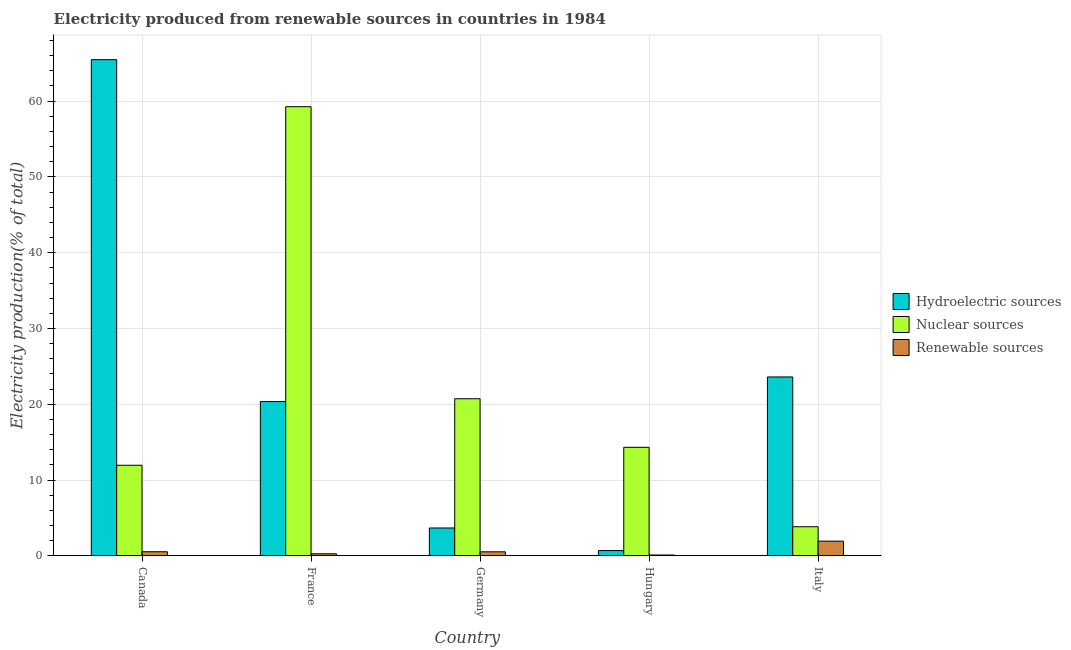How many groups of bars are there?
Give a very brief answer. 5. Are the number of bars per tick equal to the number of legend labels?
Make the answer very short. Yes. Are the number of bars on each tick of the X-axis equal?
Your answer should be compact. Yes. How many bars are there on the 2nd tick from the left?
Provide a short and direct response. 3. How many bars are there on the 1st tick from the right?
Provide a short and direct response. 3. What is the label of the 1st group of bars from the left?
Offer a terse response. Canada. In how many cases, is the number of bars for a given country not equal to the number of legend labels?
Your response must be concise. 0. What is the percentage of electricity produced by hydroelectric sources in Germany?
Make the answer very short. 3.67. Across all countries, what is the maximum percentage of electricity produced by hydroelectric sources?
Ensure brevity in your answer.  65.47. Across all countries, what is the minimum percentage of electricity produced by renewable sources?
Make the answer very short. 0.1. In which country was the percentage of electricity produced by hydroelectric sources minimum?
Provide a succinct answer. Hungary. What is the total percentage of electricity produced by nuclear sources in the graph?
Offer a terse response. 110.1. What is the difference between the percentage of electricity produced by renewable sources in Canada and that in Italy?
Provide a short and direct response. -1.4. What is the difference between the percentage of electricity produced by renewable sources in Canada and the percentage of electricity produced by hydroelectric sources in Hungary?
Make the answer very short. -0.15. What is the average percentage of electricity produced by hydroelectric sources per country?
Ensure brevity in your answer.  22.76. What is the difference between the percentage of electricity produced by hydroelectric sources and percentage of electricity produced by nuclear sources in Italy?
Your answer should be compact. 19.77. What is the ratio of the percentage of electricity produced by nuclear sources in France to that in Germany?
Ensure brevity in your answer.  2.86. Is the percentage of electricity produced by nuclear sources in Canada less than that in Hungary?
Your answer should be very brief. Yes. What is the difference between the highest and the second highest percentage of electricity produced by nuclear sources?
Provide a short and direct response. 38.54. What is the difference between the highest and the lowest percentage of electricity produced by nuclear sources?
Keep it short and to the point. 55.44. In how many countries, is the percentage of electricity produced by renewable sources greater than the average percentage of electricity produced by renewable sources taken over all countries?
Your answer should be compact. 1. What does the 1st bar from the left in Germany represents?
Your answer should be very brief. Hydroelectric sources. What does the 3rd bar from the right in France represents?
Give a very brief answer. Hydroelectric sources. How many bars are there?
Give a very brief answer. 15. How many countries are there in the graph?
Offer a terse response. 5. Does the graph contain any zero values?
Give a very brief answer. No. Does the graph contain grids?
Provide a short and direct response. Yes. Where does the legend appear in the graph?
Ensure brevity in your answer.  Center right. How many legend labels are there?
Make the answer very short. 3. What is the title of the graph?
Give a very brief answer. Electricity produced from renewable sources in countries in 1984. Does "Methane" appear as one of the legend labels in the graph?
Offer a terse response. No. What is the label or title of the X-axis?
Keep it short and to the point. Country. What is the label or title of the Y-axis?
Offer a terse response. Electricity production(% of total). What is the Electricity production(% of total) in Hydroelectric sources in Canada?
Provide a succinct answer. 65.47. What is the Electricity production(% of total) of Nuclear sources in Canada?
Your answer should be compact. 11.95. What is the Electricity production(% of total) of Renewable sources in Canada?
Give a very brief answer. 0.53. What is the Electricity production(% of total) of Hydroelectric sources in France?
Offer a terse response. 20.36. What is the Electricity production(% of total) of Nuclear sources in France?
Keep it short and to the point. 59.27. What is the Electricity production(% of total) of Renewable sources in France?
Offer a terse response. 0.27. What is the Electricity production(% of total) of Hydroelectric sources in Germany?
Offer a terse response. 3.67. What is the Electricity production(% of total) of Nuclear sources in Germany?
Offer a terse response. 20.73. What is the Electricity production(% of total) in Renewable sources in Germany?
Your response must be concise. 0.53. What is the Electricity production(% of total) of Hydroelectric sources in Hungary?
Provide a short and direct response. 0.69. What is the Electricity production(% of total) in Nuclear sources in Hungary?
Make the answer very short. 14.32. What is the Electricity production(% of total) of Renewable sources in Hungary?
Offer a very short reply. 0.1. What is the Electricity production(% of total) of Hydroelectric sources in Italy?
Offer a terse response. 23.6. What is the Electricity production(% of total) of Nuclear sources in Italy?
Keep it short and to the point. 3.83. What is the Electricity production(% of total) in Renewable sources in Italy?
Your response must be concise. 1.93. Across all countries, what is the maximum Electricity production(% of total) of Hydroelectric sources?
Give a very brief answer. 65.47. Across all countries, what is the maximum Electricity production(% of total) in Nuclear sources?
Your response must be concise. 59.27. Across all countries, what is the maximum Electricity production(% of total) of Renewable sources?
Make the answer very short. 1.93. Across all countries, what is the minimum Electricity production(% of total) of Hydroelectric sources?
Your response must be concise. 0.69. Across all countries, what is the minimum Electricity production(% of total) in Nuclear sources?
Offer a terse response. 3.83. Across all countries, what is the minimum Electricity production(% of total) of Renewable sources?
Make the answer very short. 0.1. What is the total Electricity production(% of total) of Hydroelectric sources in the graph?
Offer a terse response. 113.79. What is the total Electricity production(% of total) in Nuclear sources in the graph?
Offer a terse response. 110.1. What is the total Electricity production(% of total) in Renewable sources in the graph?
Your answer should be very brief. 3.36. What is the difference between the Electricity production(% of total) in Hydroelectric sources in Canada and that in France?
Make the answer very short. 45.12. What is the difference between the Electricity production(% of total) in Nuclear sources in Canada and that in France?
Make the answer very short. -47.32. What is the difference between the Electricity production(% of total) of Renewable sources in Canada and that in France?
Your response must be concise. 0.27. What is the difference between the Electricity production(% of total) of Hydroelectric sources in Canada and that in Germany?
Your answer should be compact. 61.8. What is the difference between the Electricity production(% of total) of Nuclear sources in Canada and that in Germany?
Make the answer very short. -8.78. What is the difference between the Electricity production(% of total) of Renewable sources in Canada and that in Germany?
Your answer should be compact. 0.01. What is the difference between the Electricity production(% of total) in Hydroelectric sources in Canada and that in Hungary?
Ensure brevity in your answer.  64.78. What is the difference between the Electricity production(% of total) in Nuclear sources in Canada and that in Hungary?
Your answer should be very brief. -2.37. What is the difference between the Electricity production(% of total) in Renewable sources in Canada and that in Hungary?
Provide a short and direct response. 0.43. What is the difference between the Electricity production(% of total) of Hydroelectric sources in Canada and that in Italy?
Your answer should be very brief. 41.87. What is the difference between the Electricity production(% of total) in Nuclear sources in Canada and that in Italy?
Offer a very short reply. 8.11. What is the difference between the Electricity production(% of total) of Renewable sources in Canada and that in Italy?
Give a very brief answer. -1.4. What is the difference between the Electricity production(% of total) of Hydroelectric sources in France and that in Germany?
Ensure brevity in your answer.  16.69. What is the difference between the Electricity production(% of total) in Nuclear sources in France and that in Germany?
Make the answer very short. 38.54. What is the difference between the Electricity production(% of total) in Renewable sources in France and that in Germany?
Your response must be concise. -0.26. What is the difference between the Electricity production(% of total) in Hydroelectric sources in France and that in Hungary?
Offer a terse response. 19.67. What is the difference between the Electricity production(% of total) of Nuclear sources in France and that in Hungary?
Provide a succinct answer. 44.95. What is the difference between the Electricity production(% of total) of Renewable sources in France and that in Hungary?
Offer a very short reply. 0.17. What is the difference between the Electricity production(% of total) in Hydroelectric sources in France and that in Italy?
Your response must be concise. -3.25. What is the difference between the Electricity production(% of total) of Nuclear sources in France and that in Italy?
Provide a short and direct response. 55.44. What is the difference between the Electricity production(% of total) of Renewable sources in France and that in Italy?
Offer a very short reply. -1.67. What is the difference between the Electricity production(% of total) in Hydroelectric sources in Germany and that in Hungary?
Offer a terse response. 2.98. What is the difference between the Electricity production(% of total) of Nuclear sources in Germany and that in Hungary?
Provide a short and direct response. 6.41. What is the difference between the Electricity production(% of total) in Renewable sources in Germany and that in Hungary?
Provide a short and direct response. 0.42. What is the difference between the Electricity production(% of total) of Hydroelectric sources in Germany and that in Italy?
Provide a succinct answer. -19.93. What is the difference between the Electricity production(% of total) in Nuclear sources in Germany and that in Italy?
Your answer should be very brief. 16.9. What is the difference between the Electricity production(% of total) of Renewable sources in Germany and that in Italy?
Ensure brevity in your answer.  -1.41. What is the difference between the Electricity production(% of total) in Hydroelectric sources in Hungary and that in Italy?
Give a very brief answer. -22.92. What is the difference between the Electricity production(% of total) of Nuclear sources in Hungary and that in Italy?
Provide a short and direct response. 10.48. What is the difference between the Electricity production(% of total) of Renewable sources in Hungary and that in Italy?
Your response must be concise. -1.83. What is the difference between the Electricity production(% of total) of Hydroelectric sources in Canada and the Electricity production(% of total) of Nuclear sources in France?
Make the answer very short. 6.2. What is the difference between the Electricity production(% of total) in Hydroelectric sources in Canada and the Electricity production(% of total) in Renewable sources in France?
Make the answer very short. 65.21. What is the difference between the Electricity production(% of total) in Nuclear sources in Canada and the Electricity production(% of total) in Renewable sources in France?
Keep it short and to the point. 11.68. What is the difference between the Electricity production(% of total) of Hydroelectric sources in Canada and the Electricity production(% of total) of Nuclear sources in Germany?
Make the answer very short. 44.74. What is the difference between the Electricity production(% of total) in Hydroelectric sources in Canada and the Electricity production(% of total) in Renewable sources in Germany?
Provide a succinct answer. 64.95. What is the difference between the Electricity production(% of total) of Nuclear sources in Canada and the Electricity production(% of total) of Renewable sources in Germany?
Offer a very short reply. 11.42. What is the difference between the Electricity production(% of total) in Hydroelectric sources in Canada and the Electricity production(% of total) in Nuclear sources in Hungary?
Provide a succinct answer. 51.16. What is the difference between the Electricity production(% of total) in Hydroelectric sources in Canada and the Electricity production(% of total) in Renewable sources in Hungary?
Offer a very short reply. 65.37. What is the difference between the Electricity production(% of total) in Nuclear sources in Canada and the Electricity production(% of total) in Renewable sources in Hungary?
Your answer should be very brief. 11.84. What is the difference between the Electricity production(% of total) in Hydroelectric sources in Canada and the Electricity production(% of total) in Nuclear sources in Italy?
Make the answer very short. 61.64. What is the difference between the Electricity production(% of total) of Hydroelectric sources in Canada and the Electricity production(% of total) of Renewable sources in Italy?
Ensure brevity in your answer.  63.54. What is the difference between the Electricity production(% of total) in Nuclear sources in Canada and the Electricity production(% of total) in Renewable sources in Italy?
Offer a very short reply. 10.01. What is the difference between the Electricity production(% of total) in Hydroelectric sources in France and the Electricity production(% of total) in Nuclear sources in Germany?
Give a very brief answer. -0.37. What is the difference between the Electricity production(% of total) of Hydroelectric sources in France and the Electricity production(% of total) of Renewable sources in Germany?
Keep it short and to the point. 19.83. What is the difference between the Electricity production(% of total) of Nuclear sources in France and the Electricity production(% of total) of Renewable sources in Germany?
Your answer should be compact. 58.74. What is the difference between the Electricity production(% of total) of Hydroelectric sources in France and the Electricity production(% of total) of Nuclear sources in Hungary?
Your response must be concise. 6.04. What is the difference between the Electricity production(% of total) of Hydroelectric sources in France and the Electricity production(% of total) of Renewable sources in Hungary?
Offer a terse response. 20.25. What is the difference between the Electricity production(% of total) in Nuclear sources in France and the Electricity production(% of total) in Renewable sources in Hungary?
Your answer should be very brief. 59.17. What is the difference between the Electricity production(% of total) of Hydroelectric sources in France and the Electricity production(% of total) of Nuclear sources in Italy?
Give a very brief answer. 16.52. What is the difference between the Electricity production(% of total) in Hydroelectric sources in France and the Electricity production(% of total) in Renewable sources in Italy?
Your answer should be very brief. 18.42. What is the difference between the Electricity production(% of total) in Nuclear sources in France and the Electricity production(% of total) in Renewable sources in Italy?
Provide a succinct answer. 57.34. What is the difference between the Electricity production(% of total) in Hydroelectric sources in Germany and the Electricity production(% of total) in Nuclear sources in Hungary?
Ensure brevity in your answer.  -10.65. What is the difference between the Electricity production(% of total) in Hydroelectric sources in Germany and the Electricity production(% of total) in Renewable sources in Hungary?
Ensure brevity in your answer.  3.57. What is the difference between the Electricity production(% of total) of Nuclear sources in Germany and the Electricity production(% of total) of Renewable sources in Hungary?
Give a very brief answer. 20.63. What is the difference between the Electricity production(% of total) of Hydroelectric sources in Germany and the Electricity production(% of total) of Nuclear sources in Italy?
Ensure brevity in your answer.  -0.16. What is the difference between the Electricity production(% of total) in Hydroelectric sources in Germany and the Electricity production(% of total) in Renewable sources in Italy?
Give a very brief answer. 1.74. What is the difference between the Electricity production(% of total) in Nuclear sources in Germany and the Electricity production(% of total) in Renewable sources in Italy?
Make the answer very short. 18.8. What is the difference between the Electricity production(% of total) in Hydroelectric sources in Hungary and the Electricity production(% of total) in Nuclear sources in Italy?
Your answer should be very brief. -3.15. What is the difference between the Electricity production(% of total) of Hydroelectric sources in Hungary and the Electricity production(% of total) of Renewable sources in Italy?
Provide a succinct answer. -1.24. What is the difference between the Electricity production(% of total) of Nuclear sources in Hungary and the Electricity production(% of total) of Renewable sources in Italy?
Provide a succinct answer. 12.38. What is the average Electricity production(% of total) in Hydroelectric sources per country?
Provide a succinct answer. 22.76. What is the average Electricity production(% of total) in Nuclear sources per country?
Your answer should be compact. 22.02. What is the average Electricity production(% of total) of Renewable sources per country?
Keep it short and to the point. 0.67. What is the difference between the Electricity production(% of total) in Hydroelectric sources and Electricity production(% of total) in Nuclear sources in Canada?
Ensure brevity in your answer.  53.53. What is the difference between the Electricity production(% of total) of Hydroelectric sources and Electricity production(% of total) of Renewable sources in Canada?
Your answer should be very brief. 64.94. What is the difference between the Electricity production(% of total) in Nuclear sources and Electricity production(% of total) in Renewable sources in Canada?
Your answer should be compact. 11.41. What is the difference between the Electricity production(% of total) of Hydroelectric sources and Electricity production(% of total) of Nuclear sources in France?
Offer a very short reply. -38.91. What is the difference between the Electricity production(% of total) in Hydroelectric sources and Electricity production(% of total) in Renewable sources in France?
Offer a terse response. 20.09. What is the difference between the Electricity production(% of total) of Nuclear sources and Electricity production(% of total) of Renewable sources in France?
Offer a terse response. 59. What is the difference between the Electricity production(% of total) in Hydroelectric sources and Electricity production(% of total) in Nuclear sources in Germany?
Provide a short and direct response. -17.06. What is the difference between the Electricity production(% of total) in Hydroelectric sources and Electricity production(% of total) in Renewable sources in Germany?
Offer a terse response. 3.15. What is the difference between the Electricity production(% of total) of Nuclear sources and Electricity production(% of total) of Renewable sources in Germany?
Give a very brief answer. 20.2. What is the difference between the Electricity production(% of total) of Hydroelectric sources and Electricity production(% of total) of Nuclear sources in Hungary?
Make the answer very short. -13.63. What is the difference between the Electricity production(% of total) in Hydroelectric sources and Electricity production(% of total) in Renewable sources in Hungary?
Your answer should be very brief. 0.59. What is the difference between the Electricity production(% of total) in Nuclear sources and Electricity production(% of total) in Renewable sources in Hungary?
Provide a short and direct response. 14.22. What is the difference between the Electricity production(% of total) in Hydroelectric sources and Electricity production(% of total) in Nuclear sources in Italy?
Ensure brevity in your answer.  19.77. What is the difference between the Electricity production(% of total) of Hydroelectric sources and Electricity production(% of total) of Renewable sources in Italy?
Your answer should be compact. 21.67. What is the difference between the Electricity production(% of total) of Nuclear sources and Electricity production(% of total) of Renewable sources in Italy?
Provide a short and direct response. 1.9. What is the ratio of the Electricity production(% of total) of Hydroelectric sources in Canada to that in France?
Make the answer very short. 3.22. What is the ratio of the Electricity production(% of total) in Nuclear sources in Canada to that in France?
Provide a succinct answer. 0.2. What is the ratio of the Electricity production(% of total) in Renewable sources in Canada to that in France?
Give a very brief answer. 2. What is the ratio of the Electricity production(% of total) of Hydroelectric sources in Canada to that in Germany?
Ensure brevity in your answer.  17.83. What is the ratio of the Electricity production(% of total) of Nuclear sources in Canada to that in Germany?
Your response must be concise. 0.58. What is the ratio of the Electricity production(% of total) of Renewable sources in Canada to that in Germany?
Keep it short and to the point. 1.02. What is the ratio of the Electricity production(% of total) of Hydroelectric sources in Canada to that in Hungary?
Give a very brief answer. 95.15. What is the ratio of the Electricity production(% of total) of Nuclear sources in Canada to that in Hungary?
Offer a terse response. 0.83. What is the ratio of the Electricity production(% of total) of Renewable sources in Canada to that in Hungary?
Your answer should be very brief. 5.21. What is the ratio of the Electricity production(% of total) in Hydroelectric sources in Canada to that in Italy?
Ensure brevity in your answer.  2.77. What is the ratio of the Electricity production(% of total) in Nuclear sources in Canada to that in Italy?
Your answer should be very brief. 3.12. What is the ratio of the Electricity production(% of total) in Renewable sources in Canada to that in Italy?
Give a very brief answer. 0.28. What is the ratio of the Electricity production(% of total) of Hydroelectric sources in France to that in Germany?
Ensure brevity in your answer.  5.55. What is the ratio of the Electricity production(% of total) in Nuclear sources in France to that in Germany?
Your answer should be very brief. 2.86. What is the ratio of the Electricity production(% of total) of Renewable sources in France to that in Germany?
Your response must be concise. 0.51. What is the ratio of the Electricity production(% of total) of Hydroelectric sources in France to that in Hungary?
Provide a short and direct response. 29.58. What is the ratio of the Electricity production(% of total) of Nuclear sources in France to that in Hungary?
Offer a terse response. 4.14. What is the ratio of the Electricity production(% of total) of Renewable sources in France to that in Hungary?
Your answer should be compact. 2.61. What is the ratio of the Electricity production(% of total) of Hydroelectric sources in France to that in Italy?
Your answer should be very brief. 0.86. What is the ratio of the Electricity production(% of total) of Nuclear sources in France to that in Italy?
Your answer should be very brief. 15.46. What is the ratio of the Electricity production(% of total) in Renewable sources in France to that in Italy?
Provide a succinct answer. 0.14. What is the ratio of the Electricity production(% of total) of Hydroelectric sources in Germany to that in Hungary?
Give a very brief answer. 5.33. What is the ratio of the Electricity production(% of total) in Nuclear sources in Germany to that in Hungary?
Your answer should be very brief. 1.45. What is the ratio of the Electricity production(% of total) of Renewable sources in Germany to that in Hungary?
Give a very brief answer. 5.12. What is the ratio of the Electricity production(% of total) of Hydroelectric sources in Germany to that in Italy?
Provide a succinct answer. 0.16. What is the ratio of the Electricity production(% of total) in Nuclear sources in Germany to that in Italy?
Your answer should be compact. 5.41. What is the ratio of the Electricity production(% of total) in Renewable sources in Germany to that in Italy?
Your answer should be compact. 0.27. What is the ratio of the Electricity production(% of total) in Hydroelectric sources in Hungary to that in Italy?
Your answer should be compact. 0.03. What is the ratio of the Electricity production(% of total) in Nuclear sources in Hungary to that in Italy?
Offer a terse response. 3.73. What is the ratio of the Electricity production(% of total) of Renewable sources in Hungary to that in Italy?
Provide a succinct answer. 0.05. What is the difference between the highest and the second highest Electricity production(% of total) of Hydroelectric sources?
Offer a terse response. 41.87. What is the difference between the highest and the second highest Electricity production(% of total) of Nuclear sources?
Offer a very short reply. 38.54. What is the difference between the highest and the second highest Electricity production(% of total) in Renewable sources?
Your answer should be very brief. 1.4. What is the difference between the highest and the lowest Electricity production(% of total) in Hydroelectric sources?
Give a very brief answer. 64.78. What is the difference between the highest and the lowest Electricity production(% of total) in Nuclear sources?
Ensure brevity in your answer.  55.44. What is the difference between the highest and the lowest Electricity production(% of total) in Renewable sources?
Give a very brief answer. 1.83. 